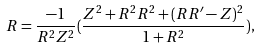<formula> <loc_0><loc_0><loc_500><loc_500>R = \frac { - 1 } { R ^ { 2 } Z ^ { 2 } } ( \frac { Z ^ { 2 } + R ^ { 2 } R ^ { 2 } + ( R R ^ { \prime } - Z ) ^ { 2 } } { 1 + R ^ { 2 } } ) ,</formula> 